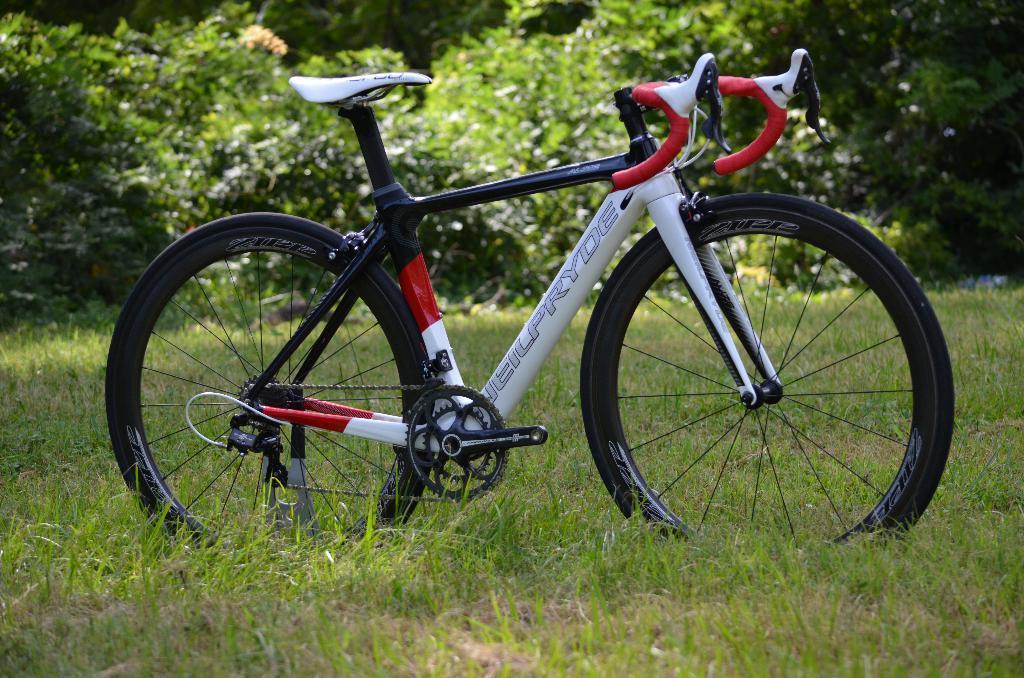Please provide a concise description of this image. In the picture we can see a grass surface on it, we can see a bicycle is parked and behind it we can see some plants. 